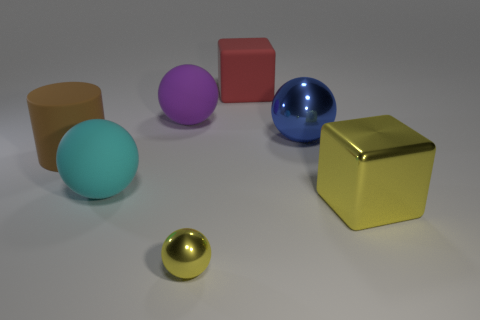Subtract all blue shiny balls. How many balls are left? 3 Subtract all blue balls. How many balls are left? 3 Add 2 big red balls. How many objects exist? 9 Subtract all purple balls. Subtract all yellow cylinders. How many balls are left? 3 Subtract 0 cyan blocks. How many objects are left? 7 Subtract all spheres. How many objects are left? 3 Subtract all red rubber cylinders. Subtract all yellow shiny balls. How many objects are left? 6 Add 1 small metal things. How many small metal things are left? 2 Add 2 small blue shiny things. How many small blue shiny things exist? 2 